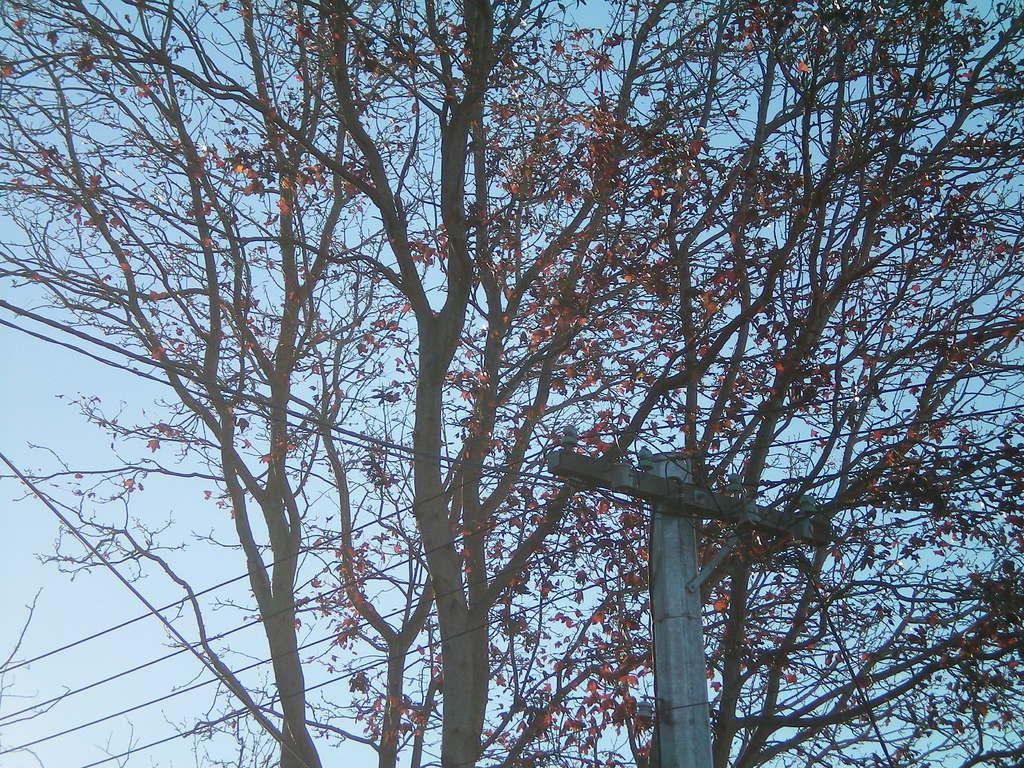What type of vegetation can be seen in the image? There are trees in the image. What object is located on the right side of the image? There is a pole on the right side of the image. What can be seen in the background of the image? The sky is visible in the background of the image. What type of food is being served in the quicksand in the image? There is no quicksand or food present in the image. What type of apparel is the tree wearing in the image? Trees do not wear apparel, and there is no person or object wearing apparel in the image. 